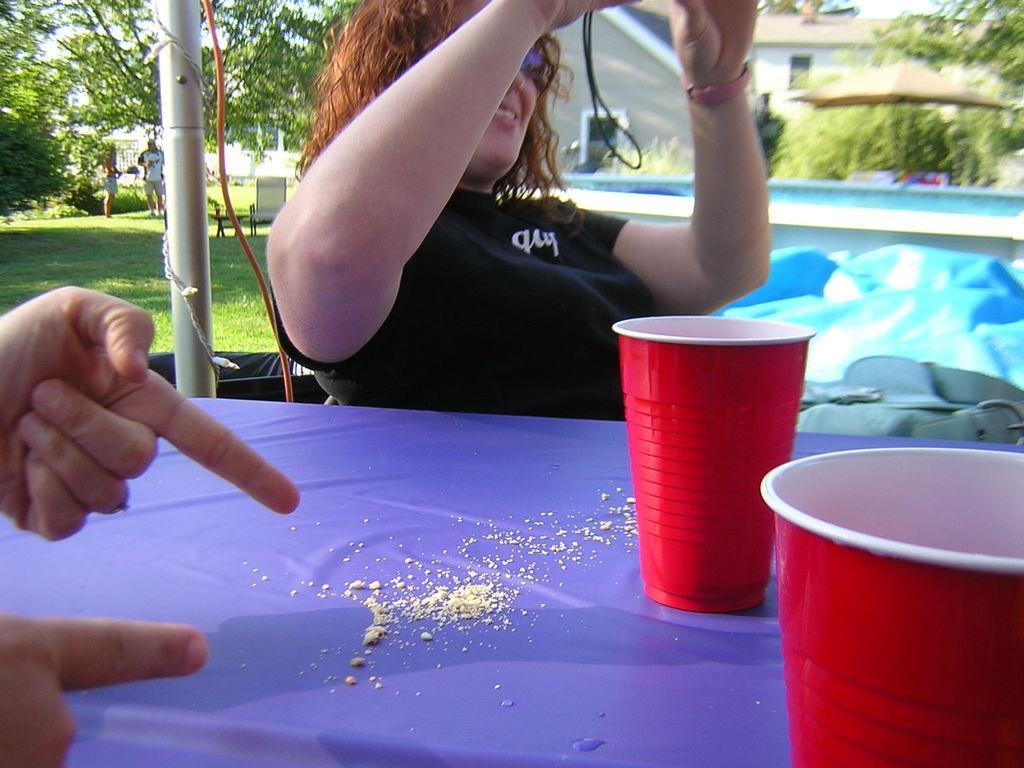How would you summarize this image in a sentence or two? In this picture we can see few people, on the right side of the image we can see two cups on the table, beside the table we can find a metal rod, in the background we can see few trees, grass, a chair and a house. 